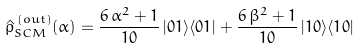<formula> <loc_0><loc_0><loc_500><loc_500>\hat { \rho } ^ { \, ( o u t ) } _ { S C M } ( \alpha ) = \frac { 6 \, \alpha ^ { 2 } + 1 } { 1 0 } \, | 0 1 \rangle \langle 0 1 | + \frac { 6 \, \beta ^ { 2 } + 1 } { 1 0 } \, | 1 0 \rangle \langle 1 0 |</formula> 